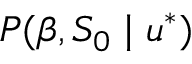Convert formula to latex. <formula><loc_0><loc_0><loc_500><loc_500>P ( \beta , S _ { 0 } | u ^ { * } )</formula> 